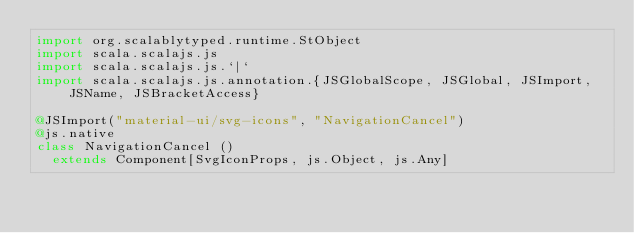Convert code to text. <code><loc_0><loc_0><loc_500><loc_500><_Scala_>import org.scalablytyped.runtime.StObject
import scala.scalajs.js
import scala.scalajs.js.`|`
import scala.scalajs.js.annotation.{JSGlobalScope, JSGlobal, JSImport, JSName, JSBracketAccess}

@JSImport("material-ui/svg-icons", "NavigationCancel")
@js.native
class NavigationCancel ()
  extends Component[SvgIconProps, js.Object, js.Any]
</code> 